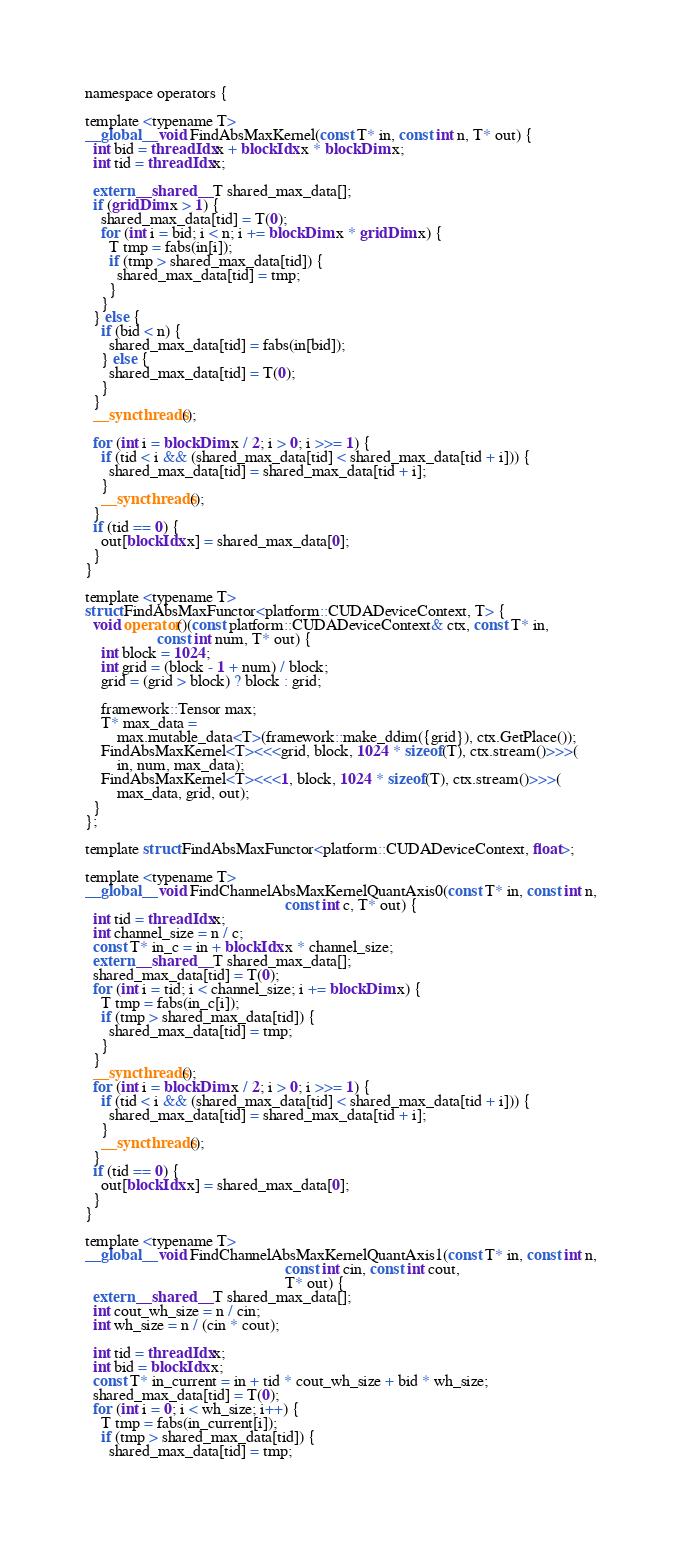Convert code to text. <code><loc_0><loc_0><loc_500><loc_500><_Cuda_>namespace operators {

template <typename T>
__global__ void FindAbsMaxKernel(const T* in, const int n, T* out) {
  int bid = threadIdx.x + blockIdx.x * blockDim.x;
  int tid = threadIdx.x;

  extern __shared__ T shared_max_data[];
  if (gridDim.x > 1) {
    shared_max_data[tid] = T(0);
    for (int i = bid; i < n; i += blockDim.x * gridDim.x) {
      T tmp = fabs(in[i]);
      if (tmp > shared_max_data[tid]) {
        shared_max_data[tid] = tmp;
      }
    }
  } else {
    if (bid < n) {
      shared_max_data[tid] = fabs(in[bid]);
    } else {
      shared_max_data[tid] = T(0);
    }
  }
  __syncthreads();

  for (int i = blockDim.x / 2; i > 0; i >>= 1) {
    if (tid < i && (shared_max_data[tid] < shared_max_data[tid + i])) {
      shared_max_data[tid] = shared_max_data[tid + i];
    }
    __syncthreads();
  }
  if (tid == 0) {
    out[blockIdx.x] = shared_max_data[0];
  }
}

template <typename T>
struct FindAbsMaxFunctor<platform::CUDADeviceContext, T> {
  void operator()(const platform::CUDADeviceContext& ctx, const T* in,
                  const int num, T* out) {
    int block = 1024;
    int grid = (block - 1 + num) / block;
    grid = (grid > block) ? block : grid;

    framework::Tensor max;
    T* max_data =
        max.mutable_data<T>(framework::make_ddim({grid}), ctx.GetPlace());
    FindAbsMaxKernel<T><<<grid, block, 1024 * sizeof(T), ctx.stream()>>>(
        in, num, max_data);
    FindAbsMaxKernel<T><<<1, block, 1024 * sizeof(T), ctx.stream()>>>(
        max_data, grid, out);
  }
};

template struct FindAbsMaxFunctor<platform::CUDADeviceContext, float>;

template <typename T>
__global__ void FindChannelAbsMaxKernelQuantAxis0(const T* in, const int n,
                                                  const int c, T* out) {
  int tid = threadIdx.x;
  int channel_size = n / c;
  const T* in_c = in + blockIdx.x * channel_size;
  extern __shared__ T shared_max_data[];
  shared_max_data[tid] = T(0);
  for (int i = tid; i < channel_size; i += blockDim.x) {
    T tmp = fabs(in_c[i]);
    if (tmp > shared_max_data[tid]) {
      shared_max_data[tid] = tmp;
    }
  }
  __syncthreads();
  for (int i = blockDim.x / 2; i > 0; i >>= 1) {
    if (tid < i && (shared_max_data[tid] < shared_max_data[tid + i])) {
      shared_max_data[tid] = shared_max_data[tid + i];
    }
    __syncthreads();
  }
  if (tid == 0) {
    out[blockIdx.x] = shared_max_data[0];
  }
}

template <typename T>
__global__ void FindChannelAbsMaxKernelQuantAxis1(const T* in, const int n,
                                                  const int cin, const int cout,
                                                  T* out) {
  extern __shared__ T shared_max_data[];
  int cout_wh_size = n / cin;
  int wh_size = n / (cin * cout);

  int tid = threadIdx.x;
  int bid = blockIdx.x;
  const T* in_current = in + tid * cout_wh_size + bid * wh_size;
  shared_max_data[tid] = T(0);
  for (int i = 0; i < wh_size; i++) {
    T tmp = fabs(in_current[i]);
    if (tmp > shared_max_data[tid]) {
      shared_max_data[tid] = tmp;</code> 